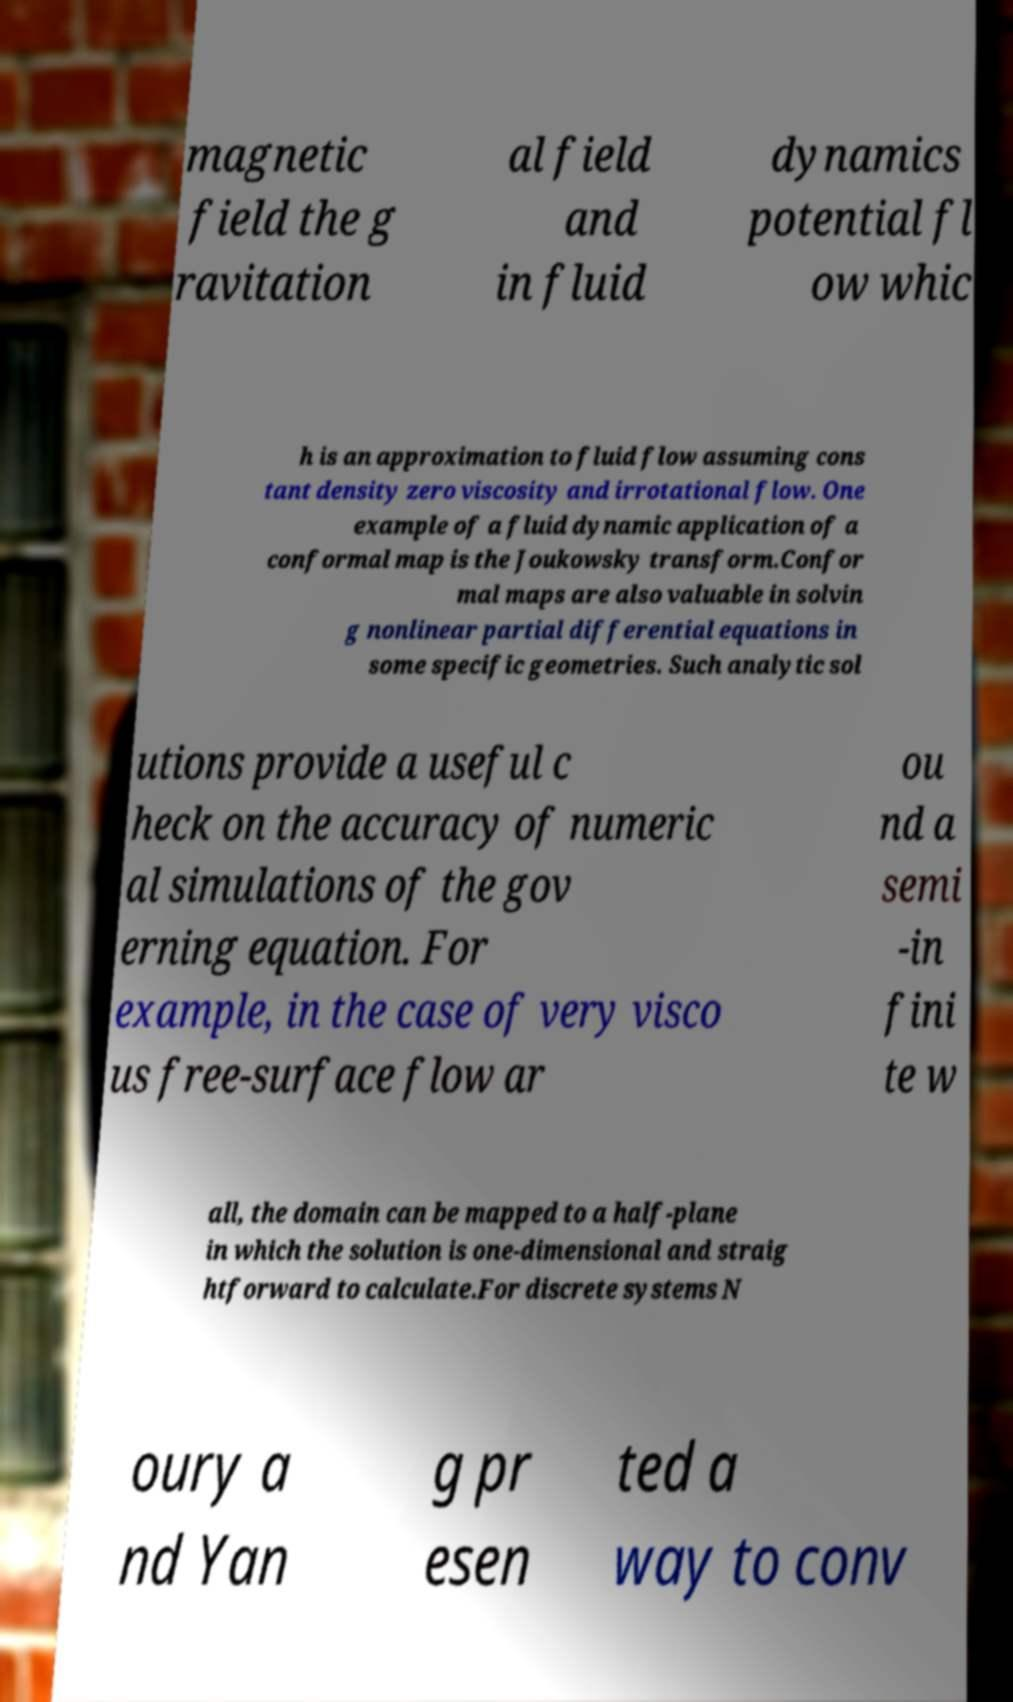Please identify and transcribe the text found in this image. magnetic field the g ravitation al field and in fluid dynamics potential fl ow whic h is an approximation to fluid flow assuming cons tant density zero viscosity and irrotational flow. One example of a fluid dynamic application of a conformal map is the Joukowsky transform.Confor mal maps are also valuable in solvin g nonlinear partial differential equations in some specific geometries. Such analytic sol utions provide a useful c heck on the accuracy of numeric al simulations of the gov erning equation. For example, in the case of very visco us free-surface flow ar ou nd a semi -in fini te w all, the domain can be mapped to a half-plane in which the solution is one-dimensional and straig htforward to calculate.For discrete systems N oury a nd Yan g pr esen ted a way to conv 